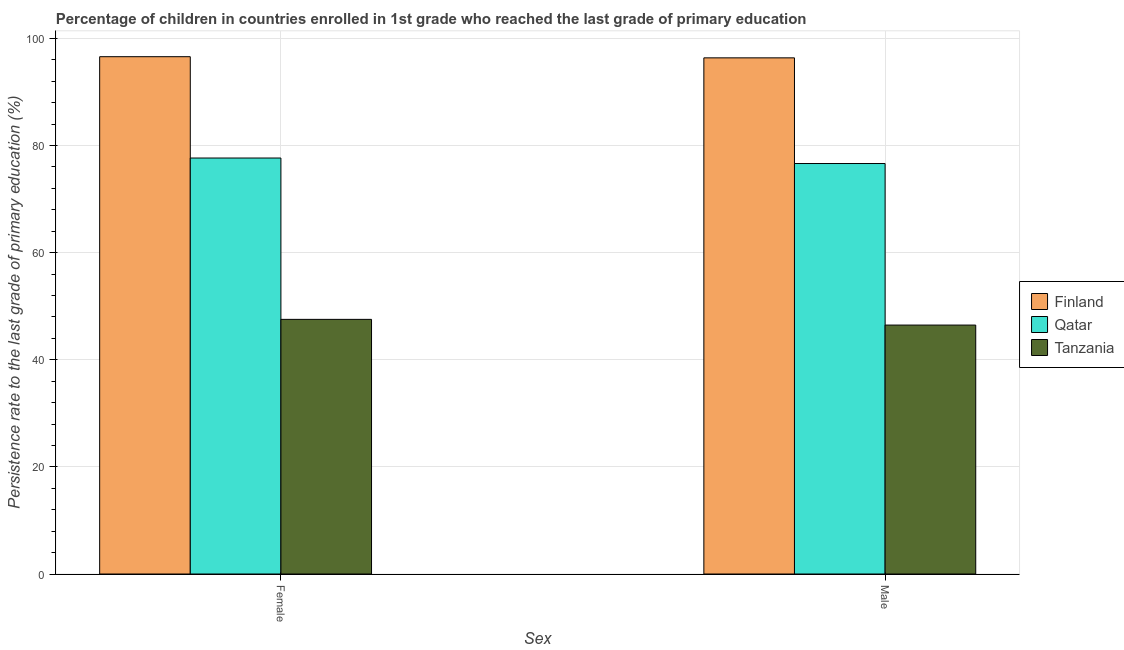Are the number of bars on each tick of the X-axis equal?
Provide a succinct answer. Yes. How many bars are there on the 2nd tick from the right?
Make the answer very short. 3. What is the persistence rate of female students in Tanzania?
Make the answer very short. 47.55. Across all countries, what is the maximum persistence rate of female students?
Give a very brief answer. 96.59. Across all countries, what is the minimum persistence rate of female students?
Your answer should be very brief. 47.55. In which country was the persistence rate of male students maximum?
Your answer should be very brief. Finland. In which country was the persistence rate of female students minimum?
Give a very brief answer. Tanzania. What is the total persistence rate of female students in the graph?
Make the answer very short. 221.81. What is the difference between the persistence rate of male students in Finland and that in Qatar?
Keep it short and to the point. 19.73. What is the difference between the persistence rate of male students in Finland and the persistence rate of female students in Tanzania?
Your answer should be very brief. 48.83. What is the average persistence rate of female students per country?
Offer a terse response. 73.94. What is the difference between the persistence rate of female students and persistence rate of male students in Qatar?
Your answer should be compact. 1.03. In how many countries, is the persistence rate of male students greater than 32 %?
Offer a terse response. 3. What is the ratio of the persistence rate of female students in Finland to that in Tanzania?
Give a very brief answer. 2.03. In how many countries, is the persistence rate of male students greater than the average persistence rate of male students taken over all countries?
Your answer should be compact. 2. What does the 2nd bar from the left in Male represents?
Provide a short and direct response. Qatar. How many bars are there?
Keep it short and to the point. 6. How many countries are there in the graph?
Your response must be concise. 3. What is the difference between two consecutive major ticks on the Y-axis?
Ensure brevity in your answer.  20. Where does the legend appear in the graph?
Make the answer very short. Center right. How many legend labels are there?
Offer a terse response. 3. How are the legend labels stacked?
Keep it short and to the point. Vertical. What is the title of the graph?
Provide a succinct answer. Percentage of children in countries enrolled in 1st grade who reached the last grade of primary education. Does "Algeria" appear as one of the legend labels in the graph?
Offer a very short reply. No. What is the label or title of the X-axis?
Your response must be concise. Sex. What is the label or title of the Y-axis?
Give a very brief answer. Persistence rate to the last grade of primary education (%). What is the Persistence rate to the last grade of primary education (%) of Finland in Female?
Your answer should be very brief. 96.59. What is the Persistence rate to the last grade of primary education (%) in Qatar in Female?
Your answer should be compact. 77.67. What is the Persistence rate to the last grade of primary education (%) in Tanzania in Female?
Provide a short and direct response. 47.55. What is the Persistence rate to the last grade of primary education (%) of Finland in Male?
Make the answer very short. 96.38. What is the Persistence rate to the last grade of primary education (%) in Qatar in Male?
Provide a succinct answer. 76.65. What is the Persistence rate to the last grade of primary education (%) in Tanzania in Male?
Offer a terse response. 46.48. Across all Sex, what is the maximum Persistence rate to the last grade of primary education (%) of Finland?
Give a very brief answer. 96.59. Across all Sex, what is the maximum Persistence rate to the last grade of primary education (%) of Qatar?
Give a very brief answer. 77.67. Across all Sex, what is the maximum Persistence rate to the last grade of primary education (%) in Tanzania?
Offer a terse response. 47.55. Across all Sex, what is the minimum Persistence rate to the last grade of primary education (%) in Finland?
Give a very brief answer. 96.38. Across all Sex, what is the minimum Persistence rate to the last grade of primary education (%) in Qatar?
Ensure brevity in your answer.  76.65. Across all Sex, what is the minimum Persistence rate to the last grade of primary education (%) in Tanzania?
Provide a succinct answer. 46.48. What is the total Persistence rate to the last grade of primary education (%) in Finland in the graph?
Your answer should be very brief. 192.97. What is the total Persistence rate to the last grade of primary education (%) of Qatar in the graph?
Provide a short and direct response. 154.32. What is the total Persistence rate to the last grade of primary education (%) of Tanzania in the graph?
Offer a very short reply. 94.03. What is the difference between the Persistence rate to the last grade of primary education (%) of Finland in Female and that in Male?
Make the answer very short. 0.22. What is the difference between the Persistence rate to the last grade of primary education (%) in Qatar in Female and that in Male?
Your answer should be very brief. 1.03. What is the difference between the Persistence rate to the last grade of primary education (%) in Tanzania in Female and that in Male?
Offer a terse response. 1.06. What is the difference between the Persistence rate to the last grade of primary education (%) of Finland in Female and the Persistence rate to the last grade of primary education (%) of Qatar in Male?
Your answer should be very brief. 19.95. What is the difference between the Persistence rate to the last grade of primary education (%) in Finland in Female and the Persistence rate to the last grade of primary education (%) in Tanzania in Male?
Offer a very short reply. 50.11. What is the difference between the Persistence rate to the last grade of primary education (%) in Qatar in Female and the Persistence rate to the last grade of primary education (%) in Tanzania in Male?
Offer a terse response. 31.19. What is the average Persistence rate to the last grade of primary education (%) of Finland per Sex?
Keep it short and to the point. 96.49. What is the average Persistence rate to the last grade of primary education (%) of Qatar per Sex?
Give a very brief answer. 77.16. What is the average Persistence rate to the last grade of primary education (%) of Tanzania per Sex?
Offer a terse response. 47.01. What is the difference between the Persistence rate to the last grade of primary education (%) of Finland and Persistence rate to the last grade of primary education (%) of Qatar in Female?
Ensure brevity in your answer.  18.92. What is the difference between the Persistence rate to the last grade of primary education (%) of Finland and Persistence rate to the last grade of primary education (%) of Tanzania in Female?
Give a very brief answer. 49.05. What is the difference between the Persistence rate to the last grade of primary education (%) of Qatar and Persistence rate to the last grade of primary education (%) of Tanzania in Female?
Provide a short and direct response. 30.13. What is the difference between the Persistence rate to the last grade of primary education (%) in Finland and Persistence rate to the last grade of primary education (%) in Qatar in Male?
Provide a short and direct response. 19.73. What is the difference between the Persistence rate to the last grade of primary education (%) in Finland and Persistence rate to the last grade of primary education (%) in Tanzania in Male?
Offer a very short reply. 49.9. What is the difference between the Persistence rate to the last grade of primary education (%) in Qatar and Persistence rate to the last grade of primary education (%) in Tanzania in Male?
Offer a very short reply. 30.17. What is the ratio of the Persistence rate to the last grade of primary education (%) of Qatar in Female to that in Male?
Your answer should be very brief. 1.01. What is the ratio of the Persistence rate to the last grade of primary education (%) of Tanzania in Female to that in Male?
Offer a very short reply. 1.02. What is the difference between the highest and the second highest Persistence rate to the last grade of primary education (%) of Finland?
Provide a short and direct response. 0.22. What is the difference between the highest and the second highest Persistence rate to the last grade of primary education (%) in Qatar?
Provide a succinct answer. 1.03. What is the difference between the highest and the second highest Persistence rate to the last grade of primary education (%) in Tanzania?
Offer a terse response. 1.06. What is the difference between the highest and the lowest Persistence rate to the last grade of primary education (%) in Finland?
Give a very brief answer. 0.22. What is the difference between the highest and the lowest Persistence rate to the last grade of primary education (%) of Tanzania?
Provide a succinct answer. 1.06. 